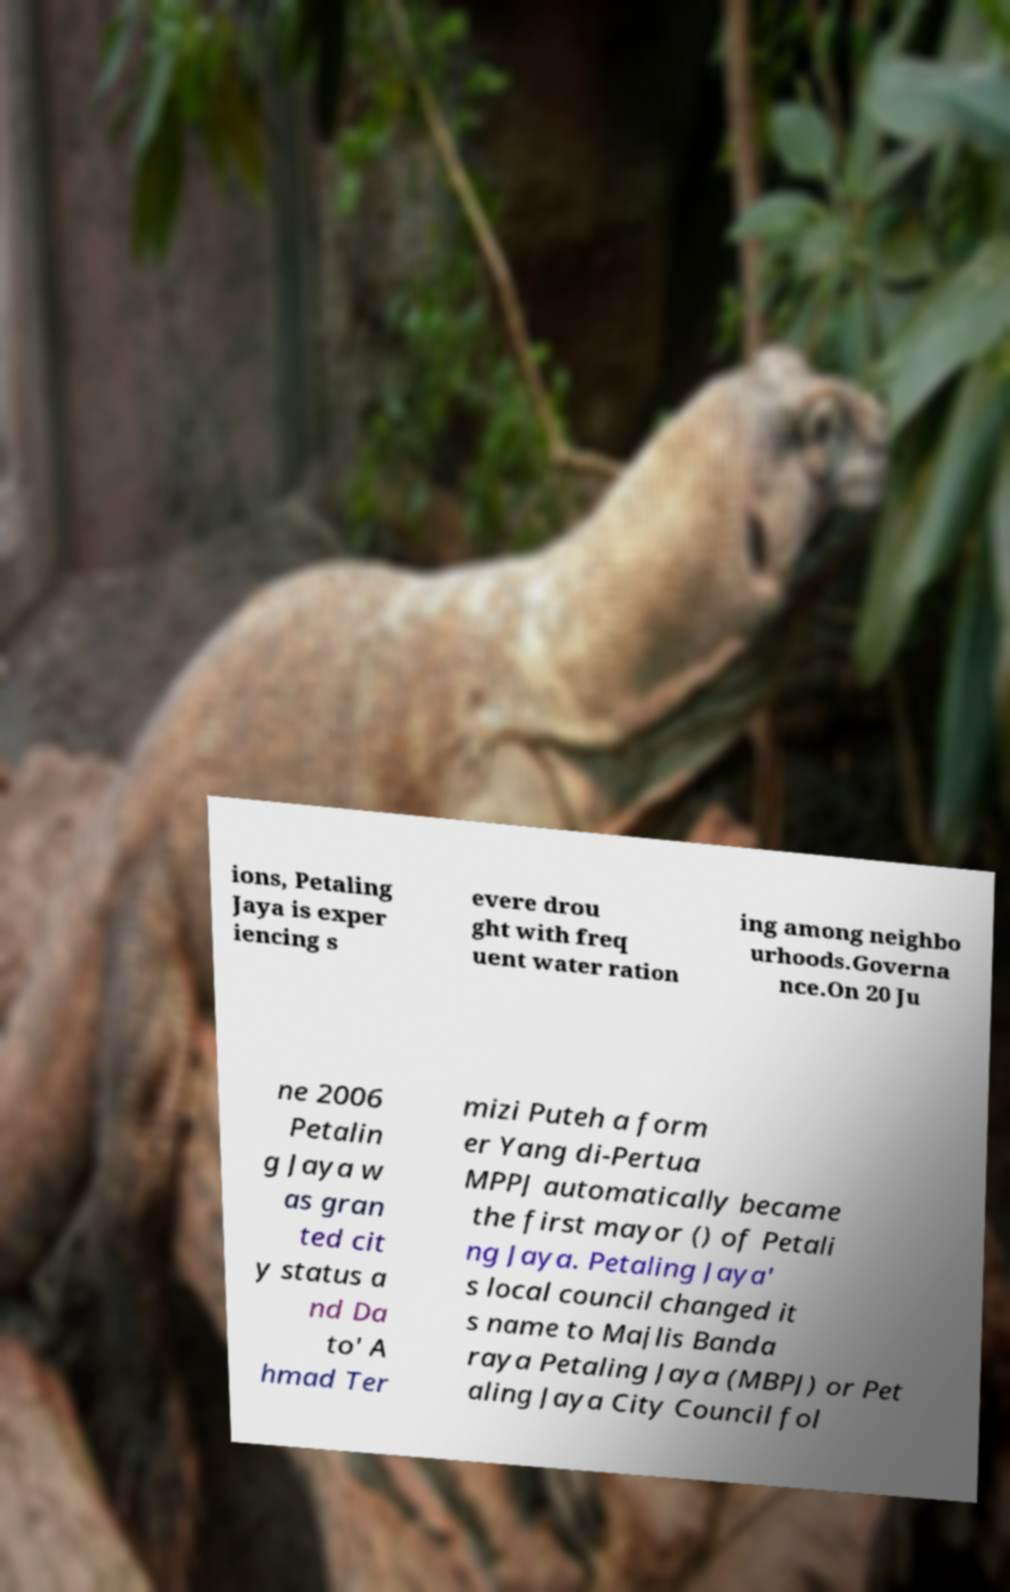Can you read and provide the text displayed in the image?This photo seems to have some interesting text. Can you extract and type it out for me? ions, Petaling Jaya is exper iencing s evere drou ght with freq uent water ration ing among neighbo urhoods.Governa nce.On 20 Ju ne 2006 Petalin g Jaya w as gran ted cit y status a nd Da to' A hmad Ter mizi Puteh a form er Yang di-Pertua MPPJ automatically became the first mayor () of Petali ng Jaya. Petaling Jaya' s local council changed it s name to Majlis Banda raya Petaling Jaya (MBPJ) or Pet aling Jaya City Council fol 